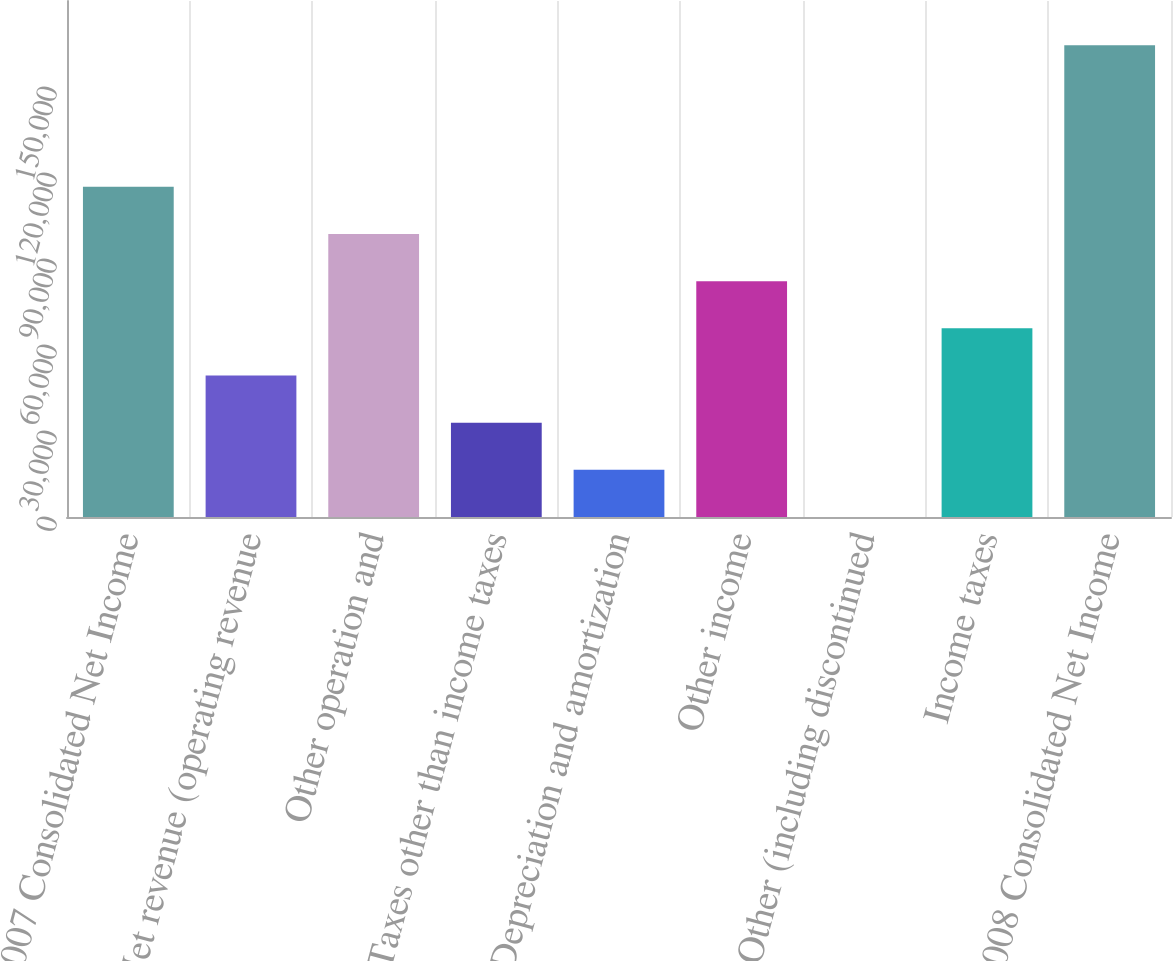<chart> <loc_0><loc_0><loc_500><loc_500><bar_chart><fcel>2007 Consolidated Net Income<fcel>Net revenue (operating revenue<fcel>Other operation and<fcel>Taxes other than income taxes<fcel>Depreciation and amortization<fcel>Other income<fcel>Other (including discontinued<fcel>Income taxes<fcel>2008 Consolidated Net Income<nl><fcel>115188<fcel>49370.2<fcel>98733.4<fcel>32915.8<fcel>16461.4<fcel>82279<fcel>7<fcel>65824.6<fcel>164551<nl></chart> 